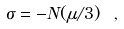<formula> <loc_0><loc_0><loc_500><loc_500>\sigma = - N ( \mu / 3 ) \ ,</formula> 